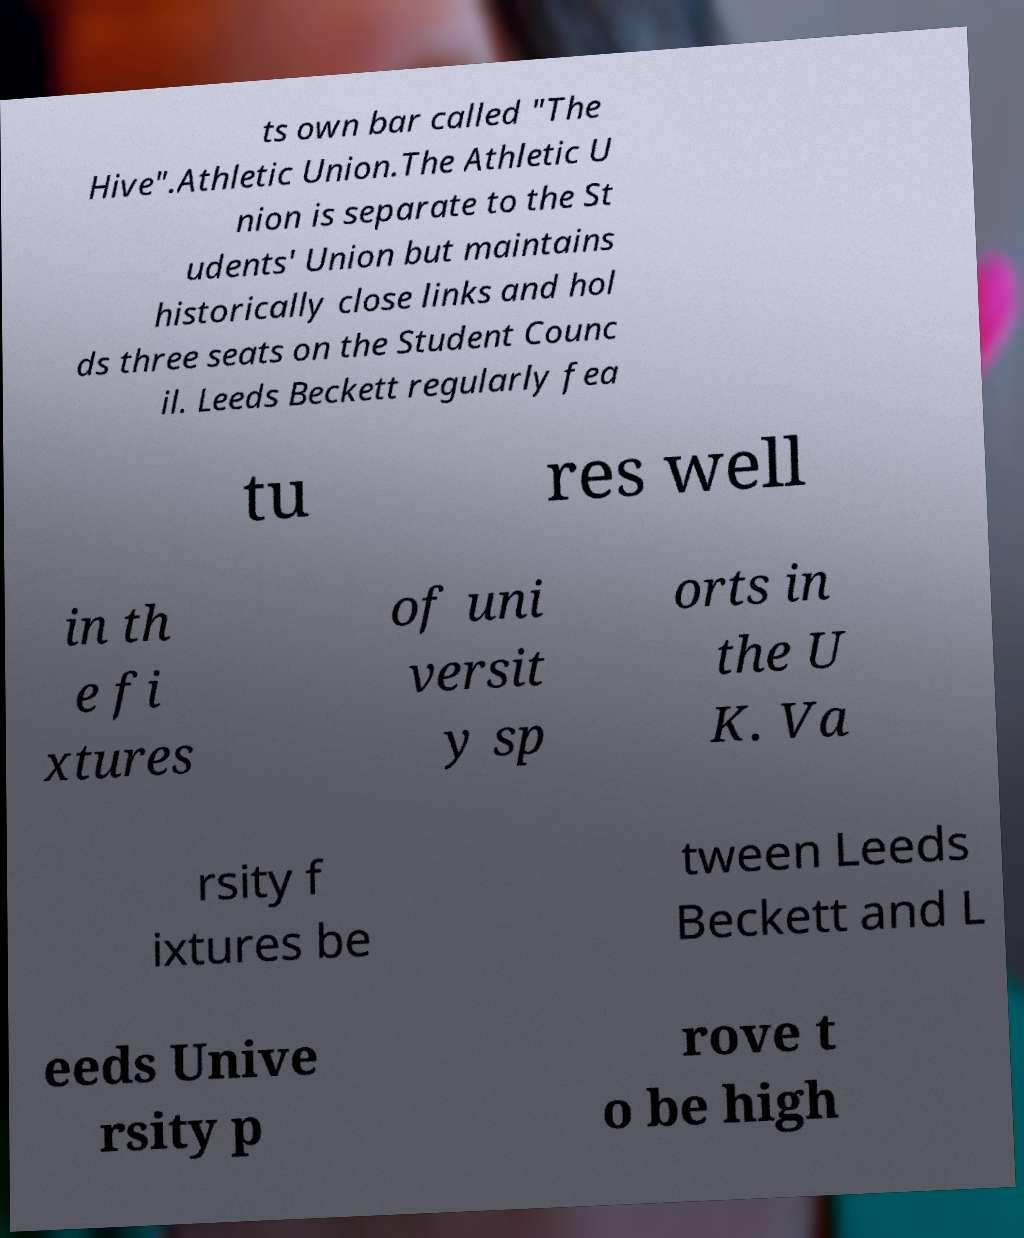Please identify and transcribe the text found in this image. ts own bar called "The Hive".Athletic Union.The Athletic U nion is separate to the St udents' Union but maintains historically close links and hol ds three seats on the Student Counc il. Leeds Beckett regularly fea tu res well in th e fi xtures of uni versit y sp orts in the U K. Va rsity f ixtures be tween Leeds Beckett and L eeds Unive rsity p rove t o be high 